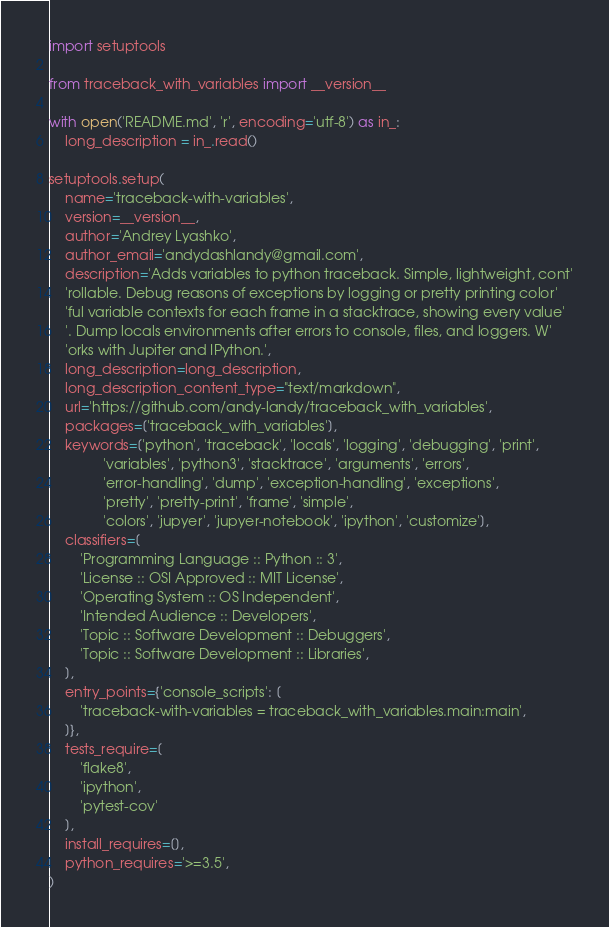<code> <loc_0><loc_0><loc_500><loc_500><_Python_>import setuptools

from traceback_with_variables import __version__

with open('README.md', 'r', encoding='utf-8') as in_:
    long_description = in_.read()

setuptools.setup(
    name='traceback-with-variables',
    version=__version__,
    author='Andrey Lyashko',
    author_email='andydashlandy@gmail.com',
    description='Adds variables to python traceback. Simple, lightweight, cont'
    'rollable. Debug reasons of exceptions by logging or pretty printing color'
    'ful variable contexts for each frame in a stacktrace, showing every value'
    '. Dump locals environments after errors to console, files, and loggers. W'
    'orks with Jupiter and IPython.',
    long_description=long_description,
    long_description_content_type="text/markdown",
    url='https://github.com/andy-landy/traceback_with_variables',
    packages=['traceback_with_variables'],
    keywords=['python', 'traceback', 'locals', 'logging', 'debugging', 'print',
              'variables', 'python3', 'stacktrace', 'arguments', 'errors',
              'error-handling', 'dump', 'exception-handling', 'exceptions',
              'pretty', 'pretty-print', 'frame', 'simple',
              'colors', 'jupyer', 'jupyer-notebook', 'ipython', 'customize'],
    classifiers=[
        'Programming Language :: Python :: 3',
        'License :: OSI Approved :: MIT License',
        'Operating System :: OS Independent',
        'Intended Audience :: Developers',
        'Topic :: Software Development :: Debuggers',
        'Topic :: Software Development :: Libraries',
    ],
    entry_points={'console_scripts': [
        'traceback-with-variables = traceback_with_variables.main:main',
    ]},
    tests_require=[
        'flake8',
        'ipython',
        'pytest-cov'
    ],
    install_requires=[],
    python_requires='>=3.5',
)
</code> 